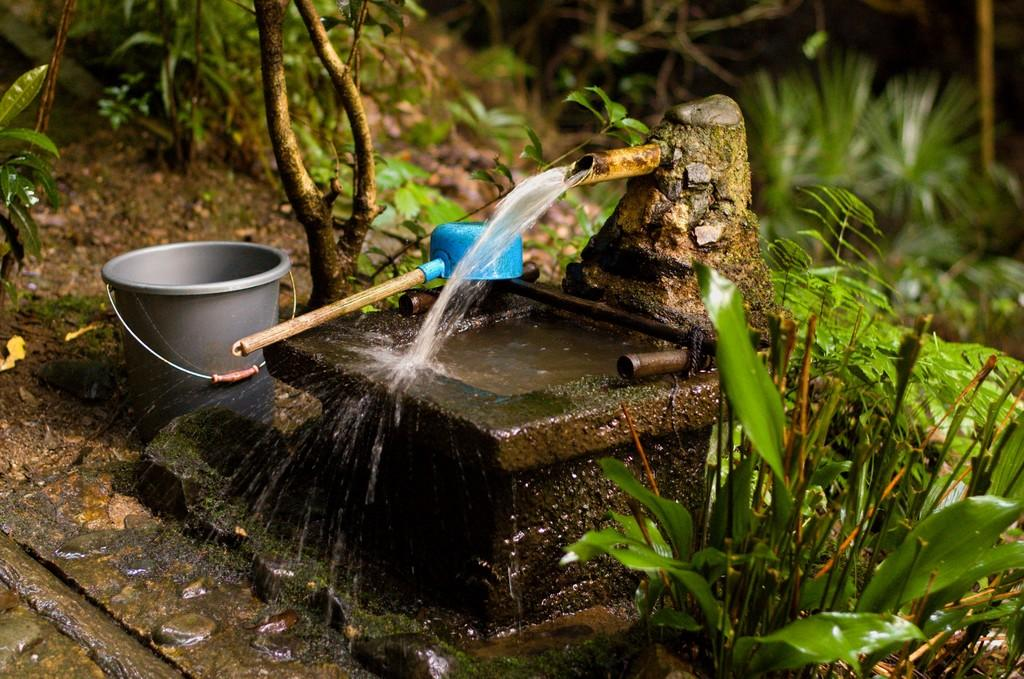What is happening with the water in the image? Water is flowing from a pipe in the image. What is on the ground near the water? There is a bucket on the ground in the image. What can be seen beside a stone in the image? There is an object placed beside a stone in the image. What type of vegetation is visible in the image? There are plants visible in the image. What type of music can be heard playing in the background of the image? There is no music present in the image, as it is a still image and does not have any audible elements. 